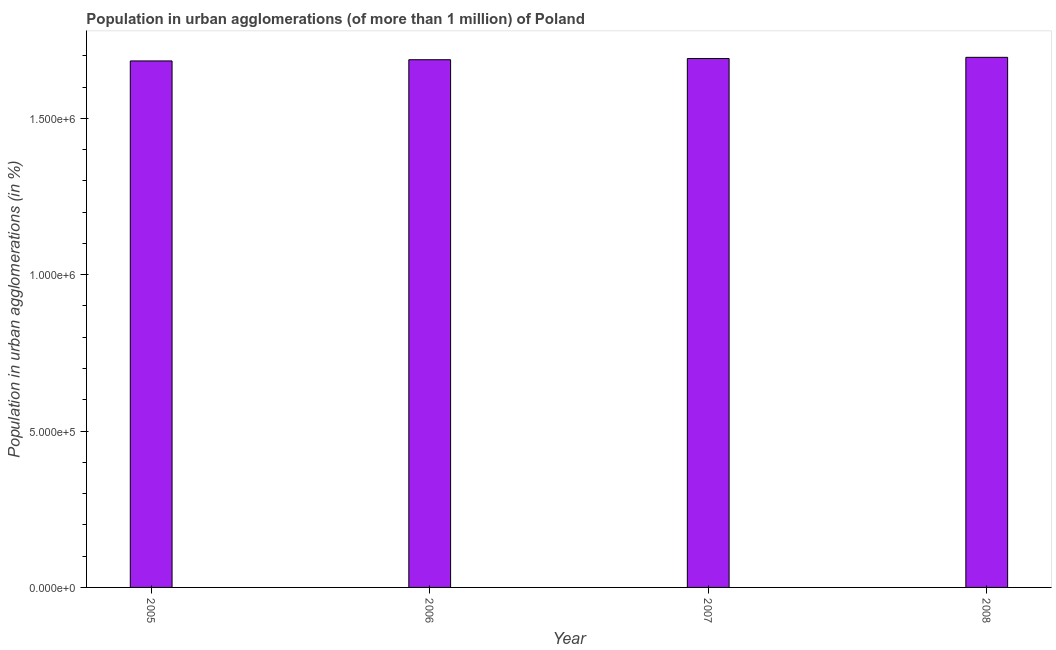Does the graph contain grids?
Offer a very short reply. No. What is the title of the graph?
Your answer should be compact. Population in urban agglomerations (of more than 1 million) of Poland. What is the label or title of the X-axis?
Your answer should be compact. Year. What is the label or title of the Y-axis?
Offer a terse response. Population in urban agglomerations (in %). What is the population in urban agglomerations in 2007?
Your response must be concise. 1.69e+06. Across all years, what is the maximum population in urban agglomerations?
Provide a short and direct response. 1.69e+06. Across all years, what is the minimum population in urban agglomerations?
Your answer should be compact. 1.68e+06. What is the sum of the population in urban agglomerations?
Provide a succinct answer. 6.76e+06. What is the difference between the population in urban agglomerations in 2006 and 2008?
Ensure brevity in your answer.  -7669. What is the average population in urban agglomerations per year?
Your answer should be very brief. 1.69e+06. What is the median population in urban agglomerations?
Your answer should be compact. 1.69e+06. Do a majority of the years between 2007 and 2005 (inclusive) have population in urban agglomerations greater than 1300000 %?
Ensure brevity in your answer.  Yes. Is the population in urban agglomerations in 2005 less than that in 2006?
Offer a terse response. Yes. Is the difference between the population in urban agglomerations in 2006 and 2008 greater than the difference between any two years?
Your answer should be compact. No. What is the difference between the highest and the second highest population in urban agglomerations?
Your answer should be very brief. 3841. Is the sum of the population in urban agglomerations in 2005 and 2007 greater than the maximum population in urban agglomerations across all years?
Offer a terse response. Yes. What is the difference between the highest and the lowest population in urban agglomerations?
Offer a very short reply. 1.15e+04. Are all the bars in the graph horizontal?
Your answer should be compact. No. How many years are there in the graph?
Offer a terse response. 4. What is the Population in urban agglomerations (in %) in 2005?
Keep it short and to the point. 1.68e+06. What is the Population in urban agglomerations (in %) in 2006?
Give a very brief answer. 1.69e+06. What is the Population in urban agglomerations (in %) in 2007?
Keep it short and to the point. 1.69e+06. What is the Population in urban agglomerations (in %) in 2008?
Keep it short and to the point. 1.69e+06. What is the difference between the Population in urban agglomerations (in %) in 2005 and 2006?
Ensure brevity in your answer.  -3818. What is the difference between the Population in urban agglomerations (in %) in 2005 and 2007?
Make the answer very short. -7646. What is the difference between the Population in urban agglomerations (in %) in 2005 and 2008?
Your response must be concise. -1.15e+04. What is the difference between the Population in urban agglomerations (in %) in 2006 and 2007?
Keep it short and to the point. -3828. What is the difference between the Population in urban agglomerations (in %) in 2006 and 2008?
Give a very brief answer. -7669. What is the difference between the Population in urban agglomerations (in %) in 2007 and 2008?
Your response must be concise. -3841. What is the ratio of the Population in urban agglomerations (in %) in 2005 to that in 2008?
Give a very brief answer. 0.99. What is the ratio of the Population in urban agglomerations (in %) in 2006 to that in 2008?
Your answer should be compact. 0.99. 